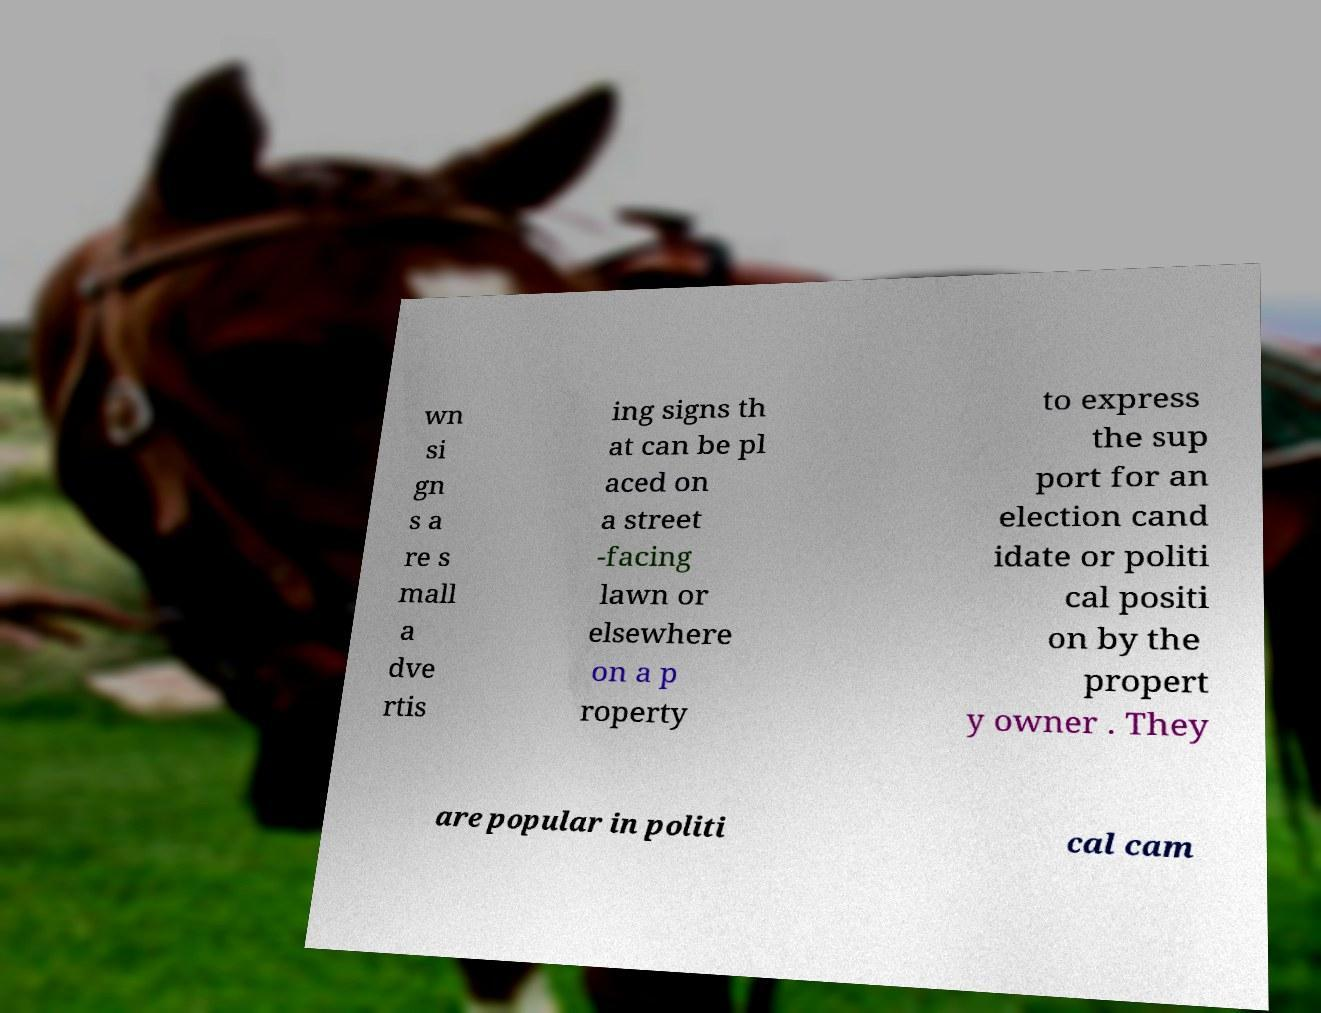What messages or text are displayed in this image? I need them in a readable, typed format. wn si gn s a re s mall a dve rtis ing signs th at can be pl aced on a street -facing lawn or elsewhere on a p roperty to express the sup port for an election cand idate or politi cal positi on by the propert y owner . They are popular in politi cal cam 